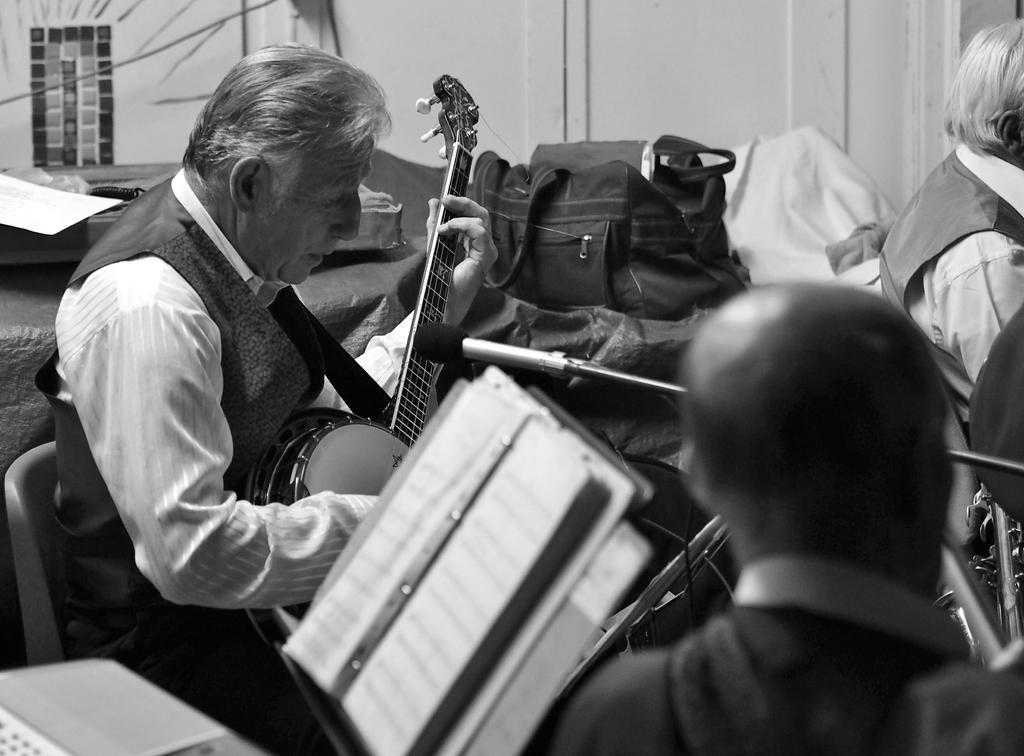Please provide a concise description of this image. Here is a old man who is wearing a coat, he is playing a guitar, there are some music notations to the right side of the old man , beside the music notations there is a person with bald head , there is also a mike and there is a bag in front of the old man, behind him there is a bed and in the background there is a wardrobe. 